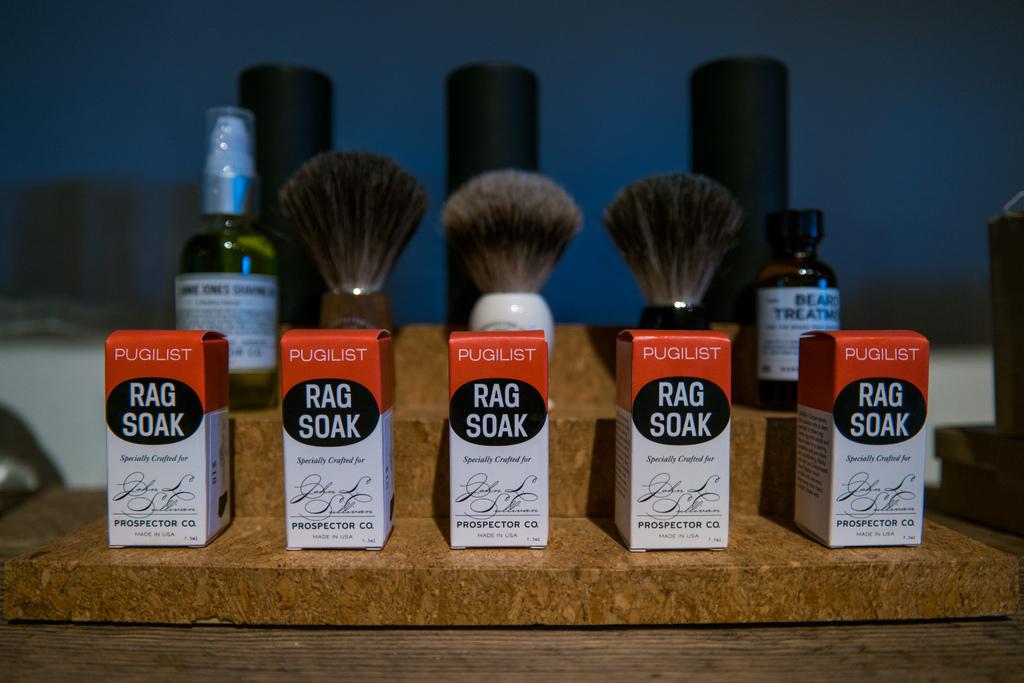What is the name of this brand?
Offer a terse response. Pugilist. What is the product in the boxes?
Provide a short and direct response. Rag soak. 